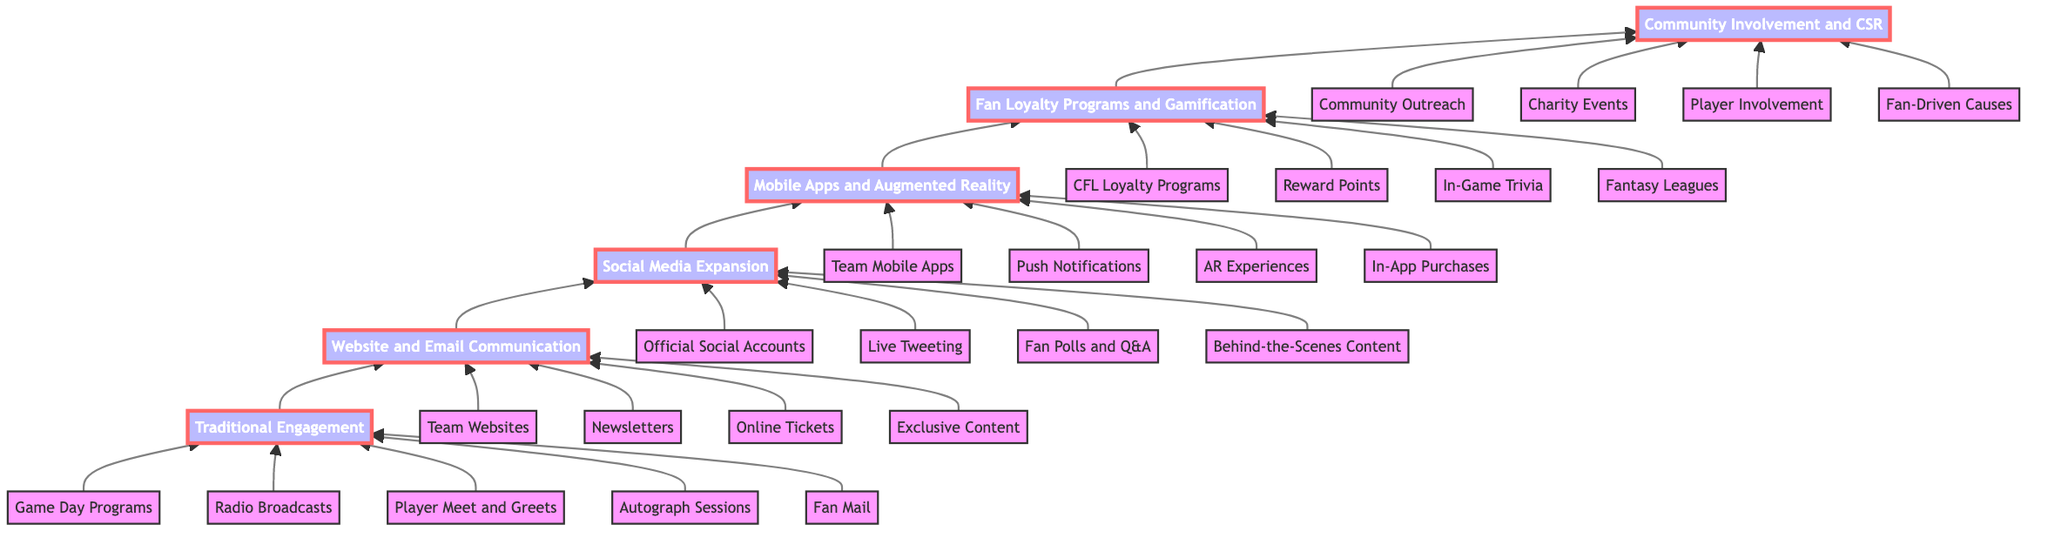What's the top stage in the diagram? The diagram's flow leads upwards where the final stage is labeled "Community Involvement and CSR," which represents the highest level of fan engagement strategies depicted.
Answer: Community Involvement and CSR How many stages are depicted in the diagram? The diagram consists of six distinct stages that represent the progression of fan engagement strategies in professional sports.
Answer: 6 What methods are included in the "Social Media Expansion" stage? The methods listed in the "Social Media Expansion" stage are "Official Team Social Media Accounts," "Live Tweeting of Games," "Fan Polls and Q&A Sessions," and "Behind-the-Scenes Videos and Stories," which enhance real-time engagement.
Answer: Official Team Social Media Accounts, Live Tweeting of Games, Fan Polls and Q&A Sessions, Behind-the-Scenes Videos and Stories Which engagement stage features "In-Game Trivia and Quizzes"? The "Fan Loyalty Programs and Gamification" stage includes "In-Game Trivia and Quizzes" as a method to enhance fan interaction and participation during games.
Answer: Fan Loyalty Programs and Gamification What is the impact of "Mobile Apps and Augmented Reality"? The impact of the "Mobile Apps and Augmented Reality" stage is described as "Enhanced user experience, personalized engagement, interactive and immersive," highlighting how technology improves fan interaction.
Answer: Enhanced user experience, personalized engagement, interactive and immersive Which method is common across the stages of engagement? The method "Team Involvement in Local Activities" from the "Community Involvement and CSR" stage reflects broader participation efforts associated with various kinds of team engagement initiatives from prior stages.
Answer: Community Outreach Initiatives, Charity Events and Fundraisers, Player Involvement in Local Activities, Fan-Driven Social Causes What is the progression of methods from "Traditional Engagement" to "Community Involvement and CSR"? The diagram illustrates that the methods progress from basic and localized interactions in "Traditional Engagement" to more interactive and community-focused strategies in "Community Involvement and CSR", emphasizing evolvement in fan engagement efforts.
Answer: Traditional Engagement > Website and Email Communication > Social Media Expansion > Mobile Apps and Augmented Reality > Fan Loyalty Programs and Gamification > Community Involvement and CSR What is a characteristic of the "Website and Email Communication" stage? This stage is characterized by broader reach and regular updates, appearing to enhance the accessibility of information for more fans compared to the traditional methods.
Answer: Broader reach and regular updates Which method listed under "Mobile Apps and Augmented Reality" may provide real-time updates? The method "Push Notifications for Updates" is found in the "Mobile Apps and Augmented Reality" stage and is designed to provide real-time updates to users on their mobile devices.
Answer: Push Notifications for Updates 